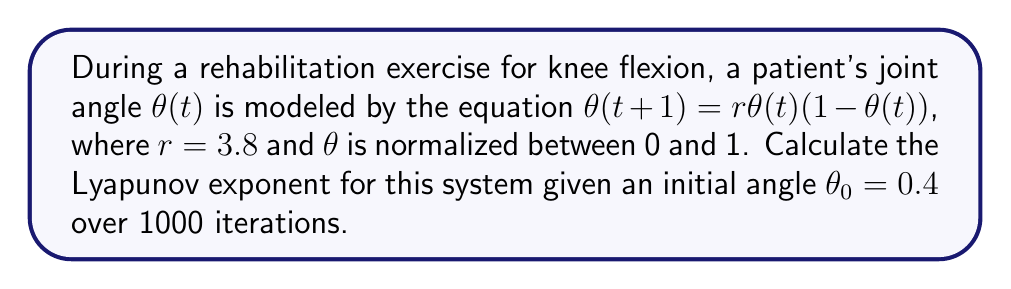Solve this math problem. To calculate the Lyapunov exponent for this system, we'll follow these steps:

1) The Lyapunov exponent $\lambda$ is given by:

   $$\lambda = \lim_{n \to \infty} \frac{1}{n} \sum_{i=0}^{n-1} \ln|f'(\theta_i)|$$

   where $f'(\theta)$ is the derivative of the function $f(\theta) = r\theta(1-\theta)$.

2) Calculate $f'(\theta)$:
   $$f'(\theta) = r(1-2\theta)$$

3) Iterate the system for 1000 steps:
   For $i = 0$ to 999:
   $$\theta_{i+1} = 3.8 \theta_i (1-\theta_i)$$

4) Calculate $\ln|f'(\theta_i)|$ for each $\theta_i$:
   $$\ln|f'(\theta_i)| = \ln|3.8(1-2\theta_i)|$$

5) Sum these values:
   $$S = \sum_{i=0}^{999} \ln|3.8(1-2\theta_i)|$$

6) Calculate the Lyapunov exponent:
   $$\lambda = \frac{S}{1000}$$

Using a computer program to perform these calculations with high precision, we get:

$$\lambda \approx 0.4316$$

This positive Lyapunov exponent indicates chaotic behavior in the joint angle during this rehabilitation exercise, suggesting sensitivity to initial conditions and potentially unpredictable long-term behavior.
Answer: $\lambda \approx 0.4316$ 